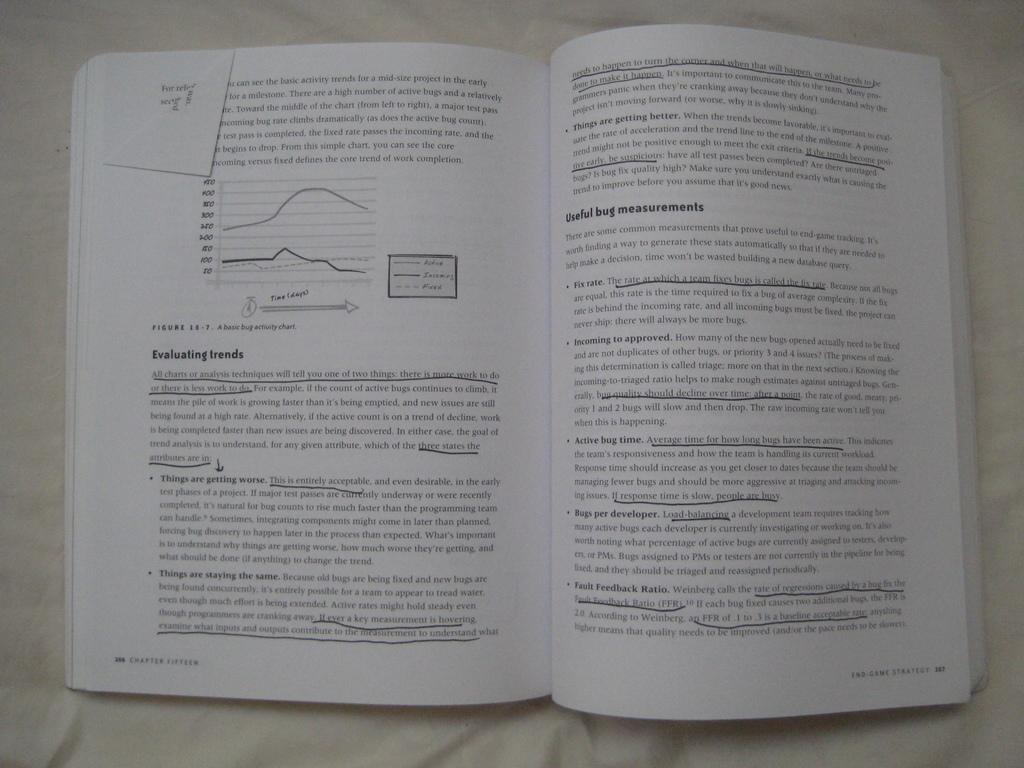<image>
Present a compact description of the photo's key features. Figure 15-7 in a book is a basic bug activity chart. 